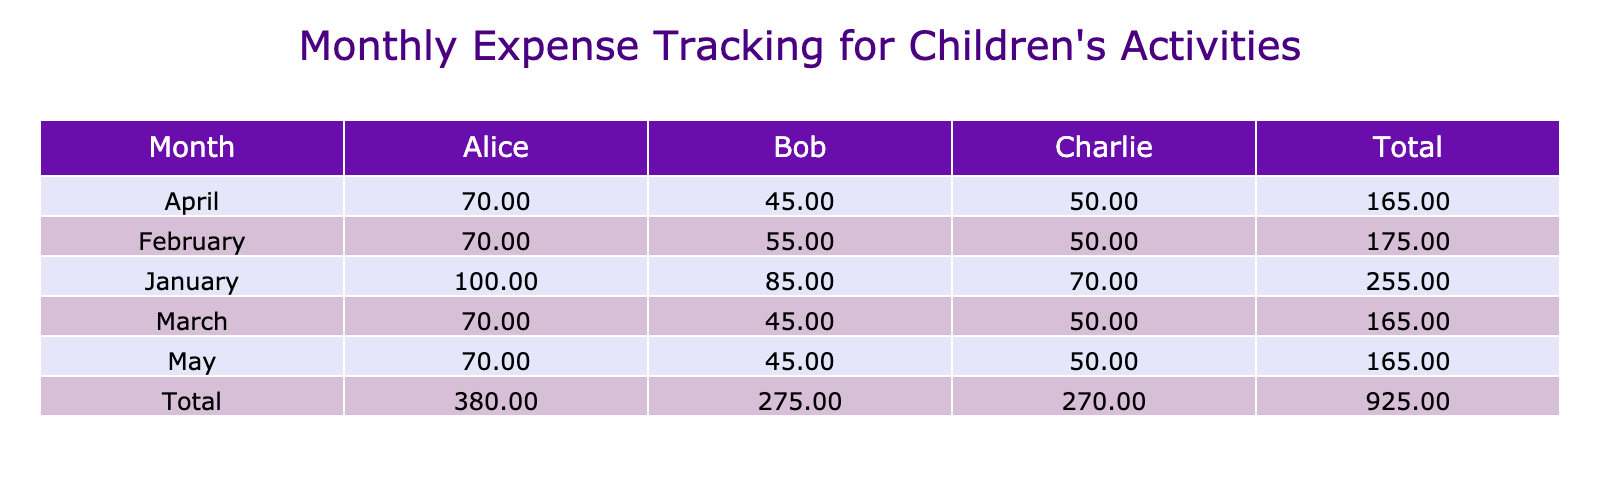What is the total cost for Alice in March? In March, Alice's total cost can be calculated by adding her activity cost, equipment cost, and transport cost: 50 + 0 + 20 = 70.
Answer: 70 How much did Bob spend on soccer over the four months? Bob's total spending on soccer can be summed across the four months: January (30), February (30), March (30), and April (30). This results in: 30 + 30 + 30 + 30 = 120.
Answer: 120 Is the equipment cost for Charlie in February higher than his swimming cost in March? In February, Charlie's equipment cost is 0, and his swimming cost in March is 40. Since 0 is less than 40, the statement is false.
Answer: No What is the monthly average total cost for all children in April? In April, the total expenses for all children are as follows: Alice (70), Bob (30), and Charlie (40), so the total is 70 + 30 + 40 = 140. There are 3 children, so the average is 140 / 3 = 46.67.
Answer: 46.67 Which month had the highest total cost and what was that cost? Summing the total costs for each month: January (150), February (120), March (120), and April (140). January has the highest total of 150.
Answer: January, 150 How many months did Alice incur an equipment cost? Alice incurred equipment costs in January (30) only, as it is the only month she has a non-zero value for equipment costs. Counting the months shows that there was one month with costs.
Answer: 1 What is the total spending across all activities for Charlie? For Charlie, we calculate the total spending for each month: January (70), February (50), March (40), and April (40). The total spending is: 70 + 50 + 40 + 40 = 200.
Answer: 200 How much did Alice spend on ballet from January to May? Alice's ballet costs for January through May are 50 each month. Therefore, the total cost is 50 * 5 = 250.
Answer: 250 Does any child have higher transport costs than their total activity costs in any month? Reviewing the data, for each child in each month, no child has transport costs greater than their activity costs. For example, Alice in January has transport costs of 20 and an activity cost of 50. Hence, the answer is no.
Answer: No 